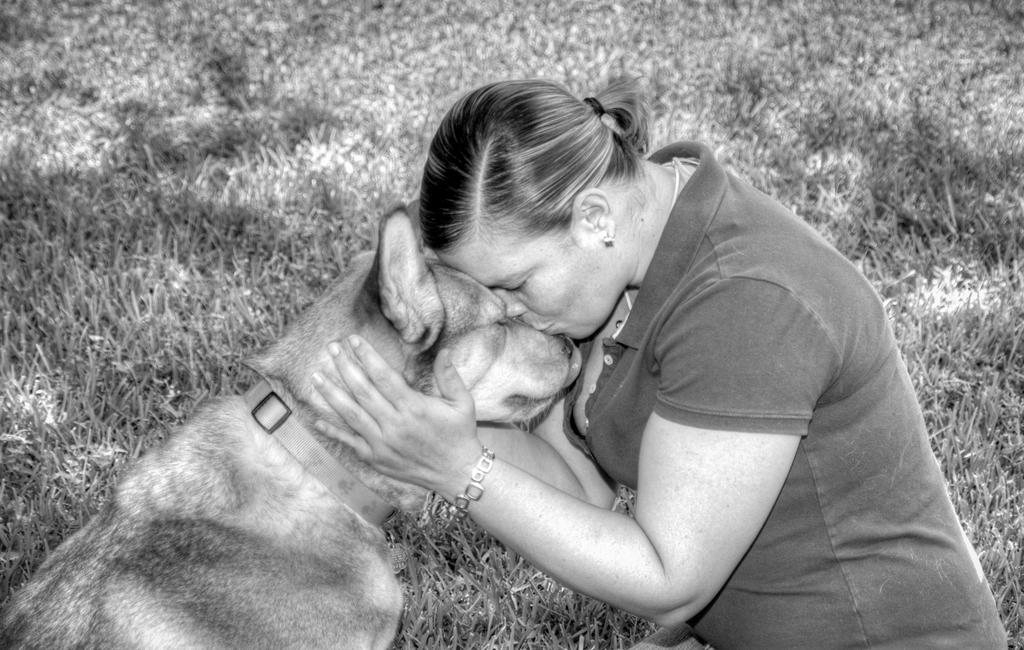Who is in the image? There is a woman in the image. What is the woman doing in the image? The woman is kissing a dog. What can be seen in the background of the image? The background of the image includes grass. What is the color scheme of the image? The image is black and white. Can you describe any accessories the woman is wearing? The woman is wearing a watch on her left hand. What type of belief is represented by the growth of the wheel in the image? There is no growth of a wheel or any representation of a belief present in the image. 